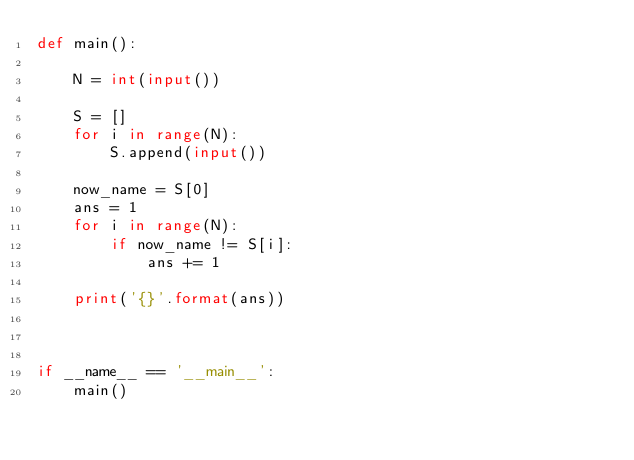Convert code to text. <code><loc_0><loc_0><loc_500><loc_500><_Python_>def main():

    N = int(input())

    S = []
    for i in range(N):
        S.append(input())
    
    now_name = S[0]
    ans = 1
    for i in range(N):
        if now_name != S[i]:
            ans += 1
    
    print('{}'.format(ans))



if __name__ == '__main__':
    main()</code> 